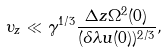<formula> <loc_0><loc_0><loc_500><loc_500>\upsilon _ { z } \ll \gamma ^ { 1 / 3 } \frac { \Delta z \Omega ^ { 2 } ( 0 ) } { ( \delta \lambda u ( 0 ) ) ^ { 2 / 3 } } ,</formula> 